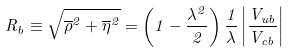Convert formula to latex. <formula><loc_0><loc_0><loc_500><loc_500>R _ { b } \equiv \sqrt { \overline { \rho } ^ { 2 } + \overline { \eta } ^ { 2 } } = \left ( 1 - \frac { \lambda ^ { 2 } } { 2 } \right ) \frac { 1 } { \lambda } \left | \frac { V _ { u b } } { V _ { c b } } \right |</formula> 